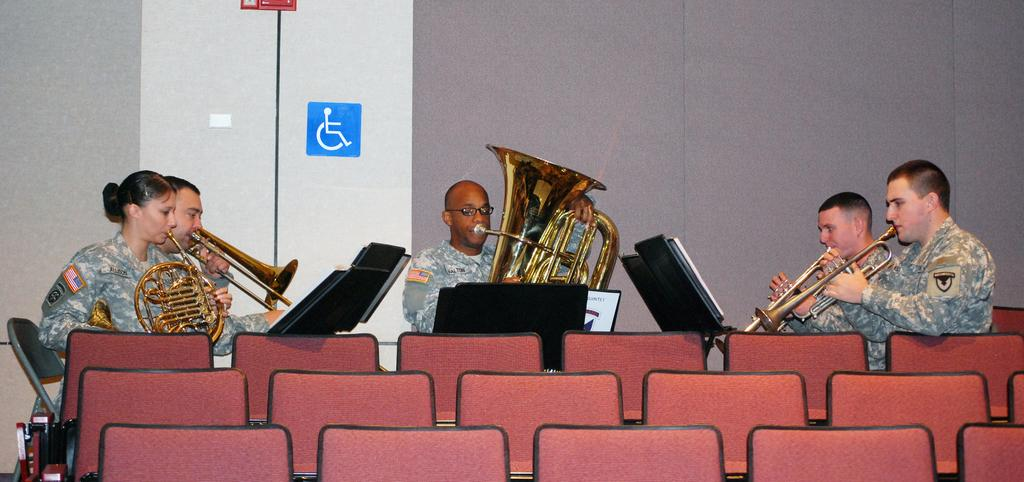What are the people in the image doing? The people in the image are sitting and holding musical instruments. What type of clothing are the people wearing? The people are wearing army clothes. What can be seen in the image that the people might be sitting on? There are chairs in the image. Is there any additional information provided in the image? Yes, there is an instruction poster and a wall in the image. Can you tell me how many basins are visible in the image? There are no basins present in the image. What type of fire can be seen burning in the image? There is no fire or burning object present in the image. 